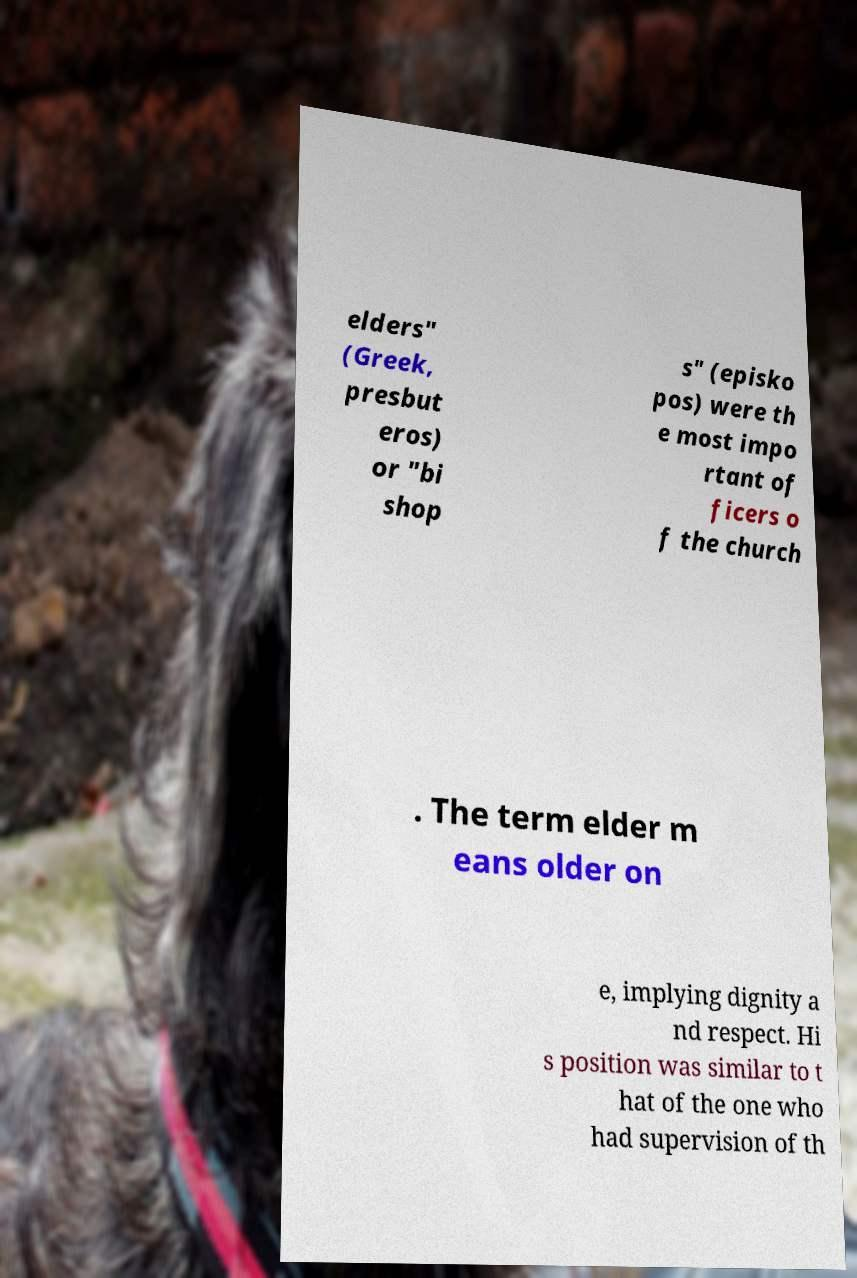Please read and relay the text visible in this image. What does it say? elders" (Greek, presbut eros) or "bi shop s" (episko pos) were th e most impo rtant of ficers o f the church . The term elder m eans older on e, implying dignity a nd respect. Hi s position was similar to t hat of the one who had supervision of th 